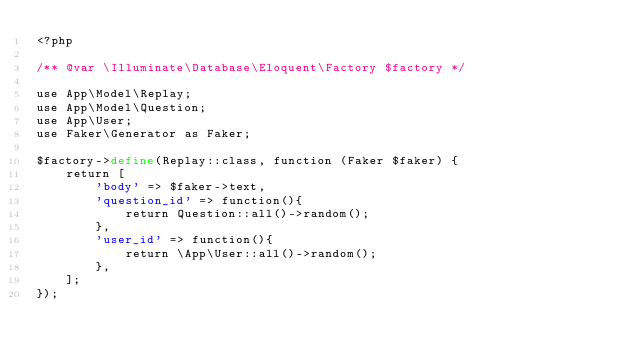<code> <loc_0><loc_0><loc_500><loc_500><_PHP_><?php

/** @var \Illuminate\Database\Eloquent\Factory $factory */

use App\Model\Replay;
use App\Model\Question;
use App\User;
use Faker\Generator as Faker;

$factory->define(Replay::class, function (Faker $faker) {
    return [
        'body' => $faker->text,
        'question_id' => function(){
            return Question::all()->random();
        },
        'user_id' => function(){
            return \App\User::all()->random();
        },
    ];
});
</code> 